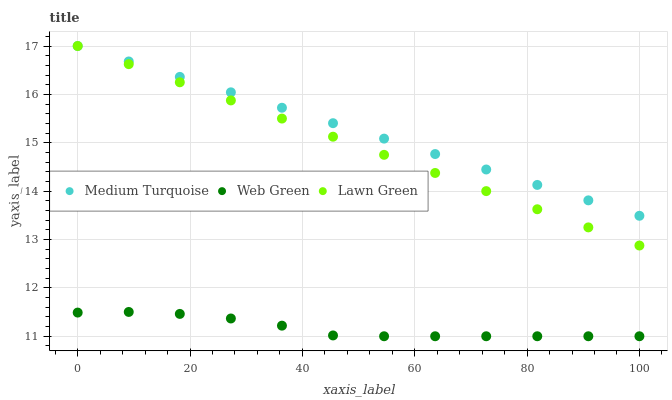Does Web Green have the minimum area under the curve?
Answer yes or no. Yes. Does Medium Turquoise have the maximum area under the curve?
Answer yes or no. Yes. Does Medium Turquoise have the minimum area under the curve?
Answer yes or no. No. Does Web Green have the maximum area under the curve?
Answer yes or no. No. Is Medium Turquoise the smoothest?
Answer yes or no. Yes. Is Web Green the roughest?
Answer yes or no. Yes. Is Web Green the smoothest?
Answer yes or no. No. Is Medium Turquoise the roughest?
Answer yes or no. No. Does Web Green have the lowest value?
Answer yes or no. Yes. Does Medium Turquoise have the lowest value?
Answer yes or no. No. Does Medium Turquoise have the highest value?
Answer yes or no. Yes. Does Web Green have the highest value?
Answer yes or no. No. Is Web Green less than Lawn Green?
Answer yes or no. Yes. Is Lawn Green greater than Web Green?
Answer yes or no. Yes. Does Lawn Green intersect Medium Turquoise?
Answer yes or no. Yes. Is Lawn Green less than Medium Turquoise?
Answer yes or no. No. Is Lawn Green greater than Medium Turquoise?
Answer yes or no. No. Does Web Green intersect Lawn Green?
Answer yes or no. No. 